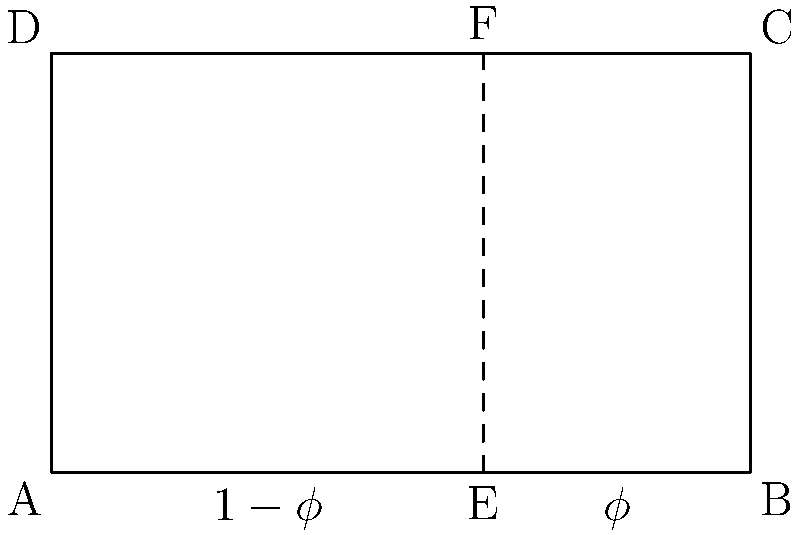In the rectangular room layout shown, the vertical dashed line represents a division based on the golden ratio. If the width of the room is 5 units, what is the approximate length of the smaller section (AE) to the nearest tenth of a unit? To solve this problem, we'll follow these steps:

1. Recall that the golden ratio, denoted by $\phi$ (phi), is approximately 1.618.

2. In the golden ratio, the ratio of the larger part to the whole is equal to the ratio of the smaller part to the larger part. This can be expressed as:

   $\frac{\text{larger}}{\text{whole}} = \frac{\text{smaller}}{\text{larger}} = \frac{1}{\phi}$

3. The width of the room is 5 units, which represents the whole.

4. The larger section (EB) represents $\phi$ of the total width, while the smaller section (AE) represents $1-\phi$ of the total width.

5. To find the length of AE, we calculate:

   $AE = 5 \times (1-\phi)$

6. $\phi \approx 1.618$, so $1-\phi \approx 1 - 1.618 = -0.618$

7. Therefore, $AE \approx 5 \times (-0.618) = -3.09$

8. Since we're dealing with length, we take the absolute value: $|AE| \approx 3.09$

9. Rounding to the nearest tenth: $AE \approx 3.1$ units
Answer: 3.1 units 